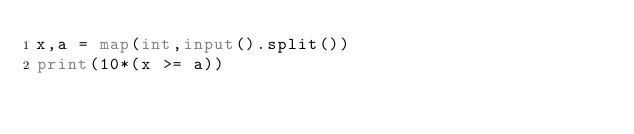<code> <loc_0><loc_0><loc_500><loc_500><_Python_>x,a = map(int,input().split())
print(10*(x >= a))</code> 